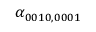Convert formula to latex. <formula><loc_0><loc_0><loc_500><loc_500>\alpha _ { 0 0 1 0 , 0 0 0 1 }</formula> 